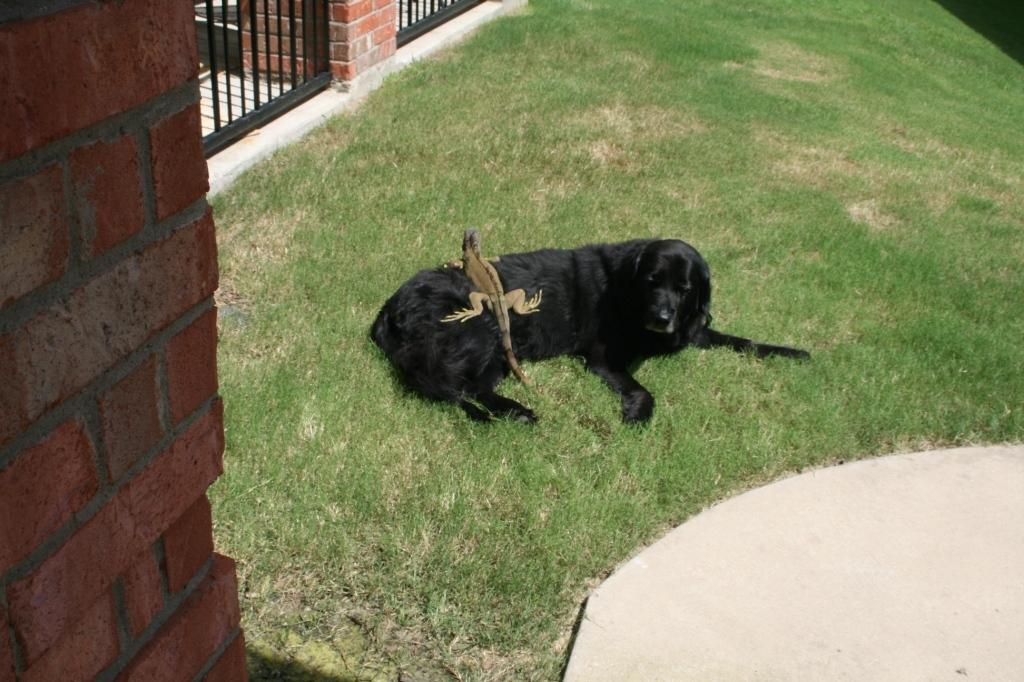What is the unusual interaction happening in the image? There is a reptile on a dog in the image. What type of vegetation can be seen in the image? There is grass in the image. What is located on the left side of the image? There is a brick wall on the left side of the image. What architectural features are visible in the background of the image? There are grilles and a wall in the background of the image. What type of cactus can be seen in the image? There is no cactus present in the image. How many volleyballs are visible in the image? There are no volleyballs present in the image. 